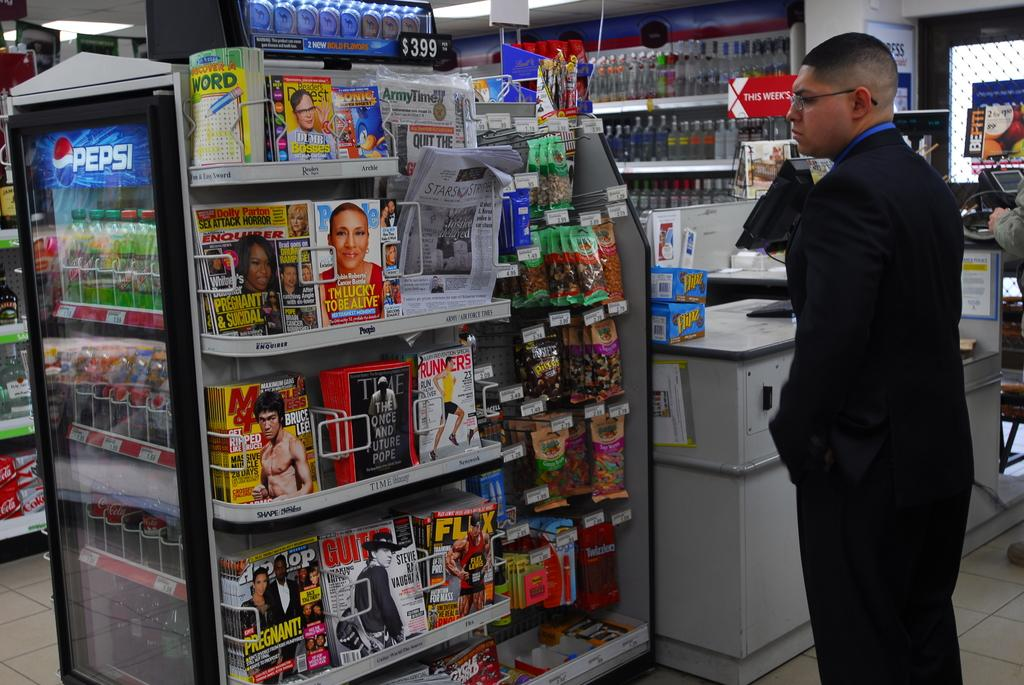Provide a one-sentence caption for the provided image. a checkout aisle in a store that has magazines on it with one of them titled 'i'm lucky to be alive'. 